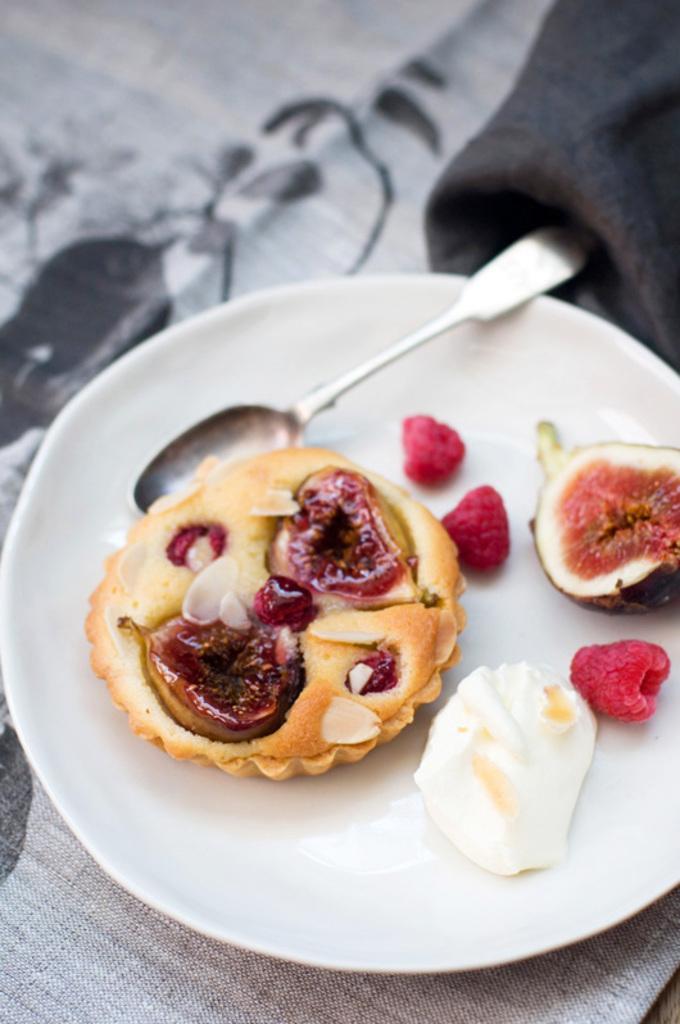In one or two sentences, can you explain what this image depicts? In this picture we can see food, fruits and a spoon on a white plate kept on the grey table cloth. 